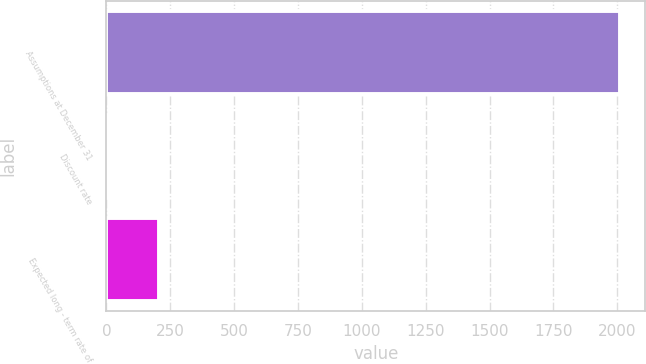<chart> <loc_0><loc_0><loc_500><loc_500><bar_chart><fcel>Assumptions at December 31<fcel>Discount rate<fcel>Expected long - term rate of<nl><fcel>2009<fcel>6.42<fcel>206.68<nl></chart> 